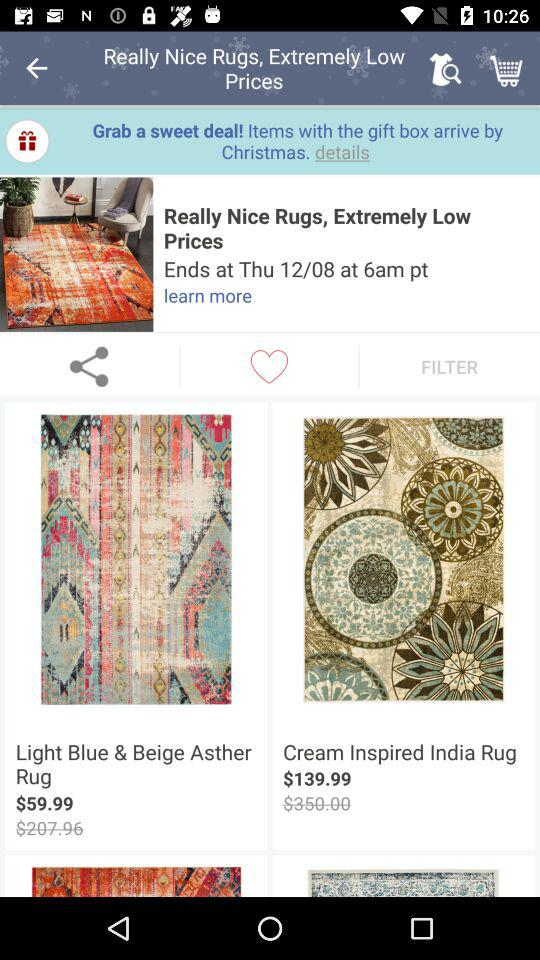How much more is the price of the second item than the first item?
Answer the question using a single word or phrase. $80.00 